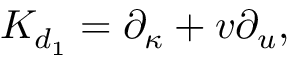<formula> <loc_0><loc_0><loc_500><loc_500>{ K } _ { d _ { 1 } } = \partial _ { \kappa } + v \partial _ { u } ,</formula> 